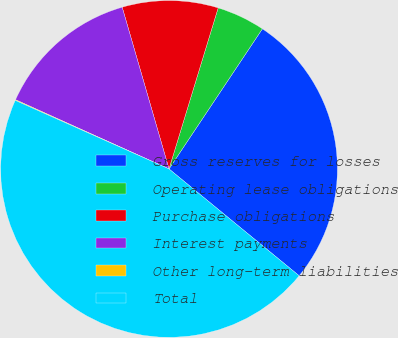Convert chart. <chart><loc_0><loc_0><loc_500><loc_500><pie_chart><fcel>Gross reserves for losses<fcel>Operating lease obligations<fcel>Purchase obligations<fcel>Interest payments<fcel>Other long-term liabilities<fcel>Total<nl><fcel>26.58%<fcel>4.64%<fcel>9.2%<fcel>13.77%<fcel>0.07%<fcel>45.73%<nl></chart> 